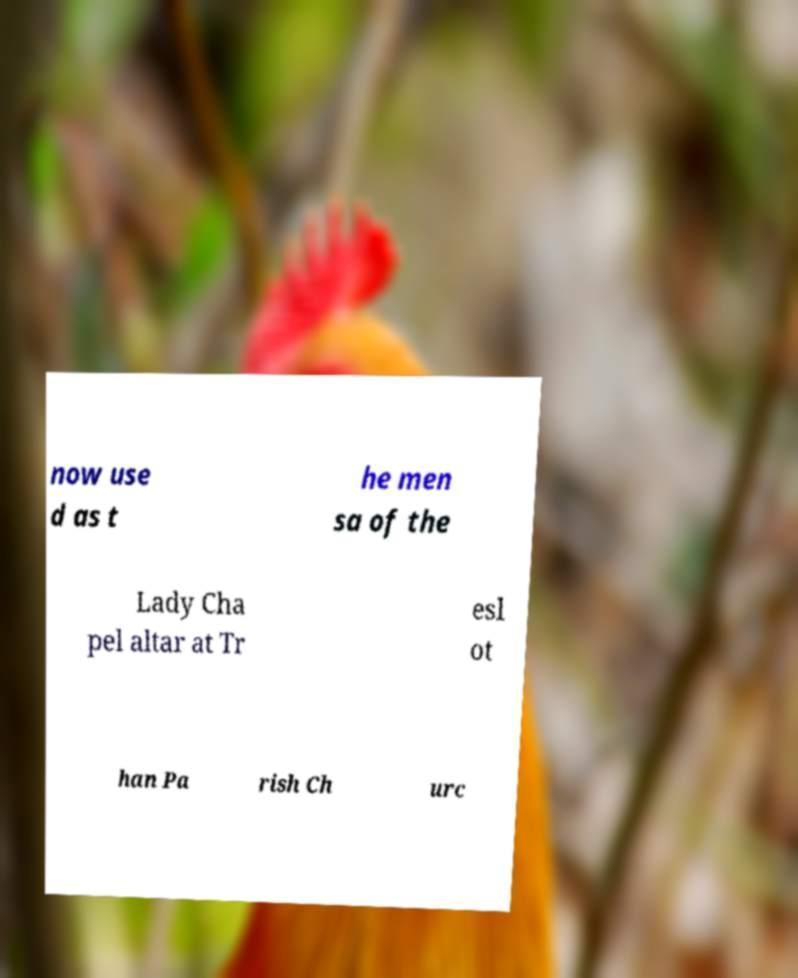Please read and relay the text visible in this image. What does it say? now use d as t he men sa of the Lady Cha pel altar at Tr esl ot han Pa rish Ch urc 